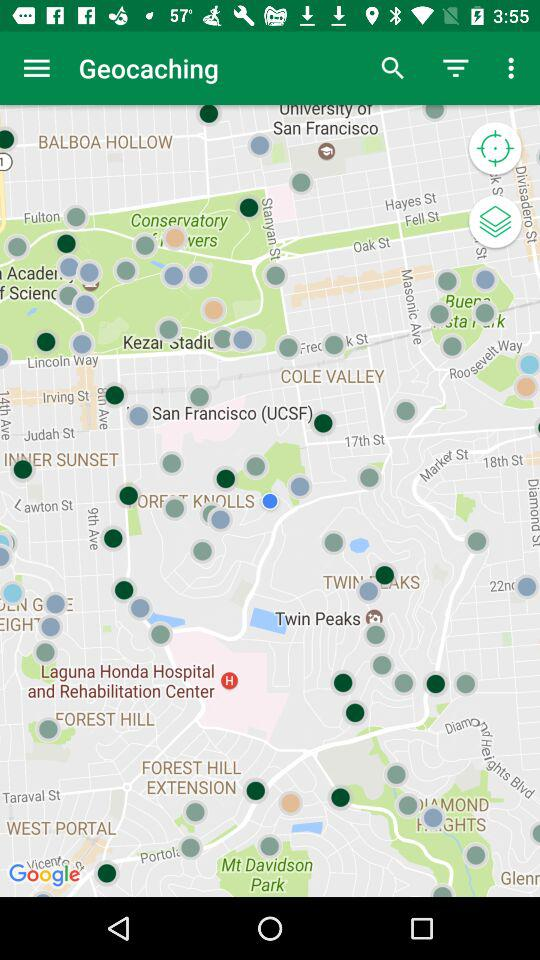What is the name of the application? The name of the application is "Geocaching". 